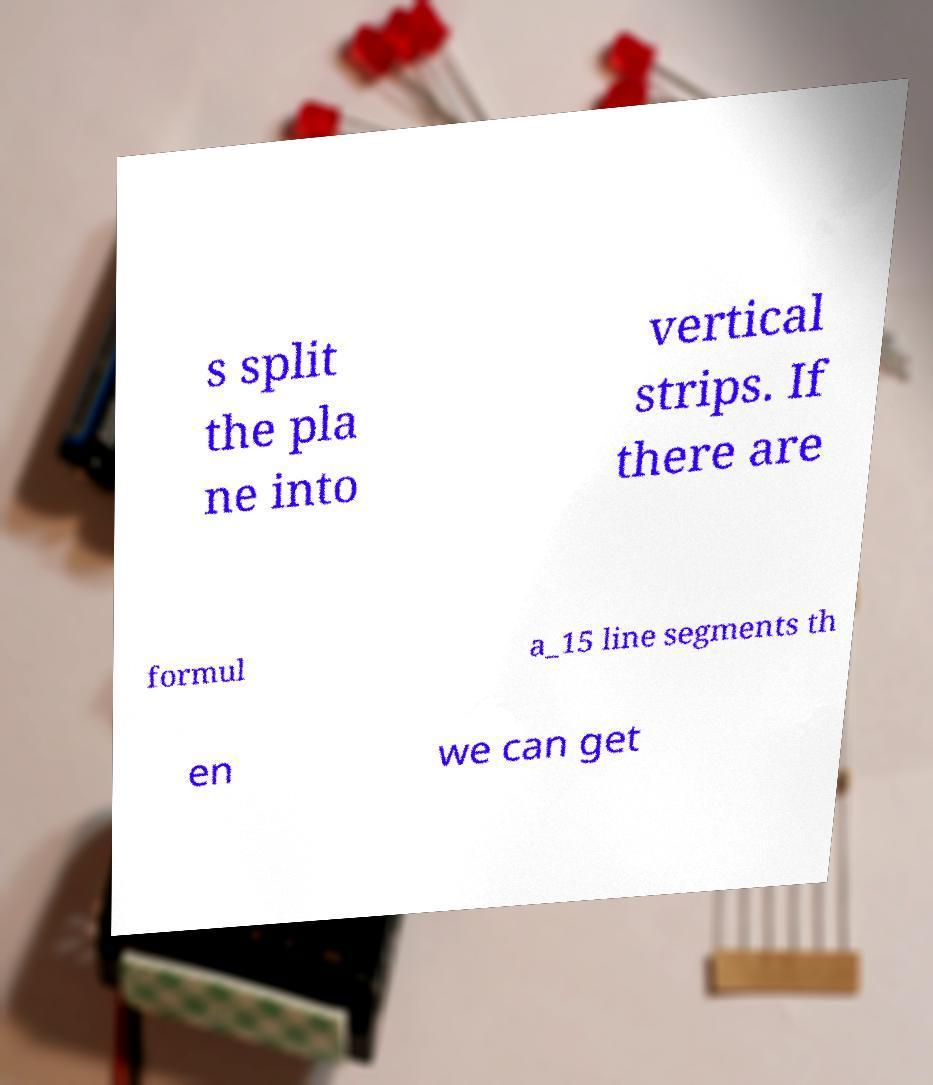Can you accurately transcribe the text from the provided image for me? s split the pla ne into vertical strips. If there are formul a_15 line segments th en we can get 